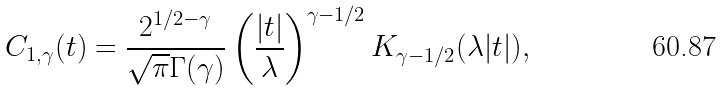Convert formula to latex. <formula><loc_0><loc_0><loc_500><loc_500>C _ { 1 , \gamma } ( t ) = \frac { 2 ^ { 1 / 2 - \gamma } } { \sqrt { \pi } \Gamma ( \gamma ) } \left ( \frac { | t | } { \lambda } \right ) ^ { \gamma - 1 / 2 } K _ { \gamma - 1 / 2 } ( \lambda | t | ) ,</formula> 